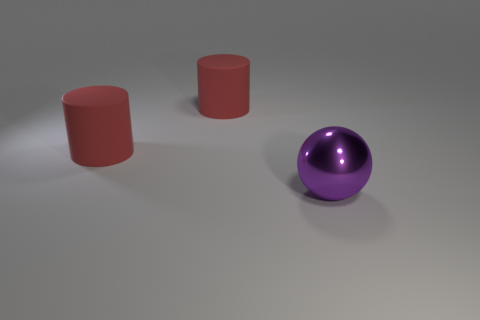Is there any other thing that has the same material as the purple object?
Provide a short and direct response. No. Is there a shiny cylinder of the same color as the big metallic object?
Your answer should be compact. No. How many matte things are either big spheres or big cylinders?
Your answer should be compact. 2. Are there any purple balls that have the same material as the large purple object?
Provide a succinct answer. No. There is a large metallic object; what number of red rubber cylinders are behind it?
Your answer should be very brief. 2. How many large red cylinders are there?
Give a very brief answer. 2. What is the size of the purple metal object?
Your response must be concise. Large. What number of other objects are the same material as the big purple sphere?
Your response must be concise. 0. Are there more balls than big red matte cylinders?
Offer a terse response. No. How many things are either big things that are left of the metallic sphere or large shiny objects?
Your answer should be compact. 3. 